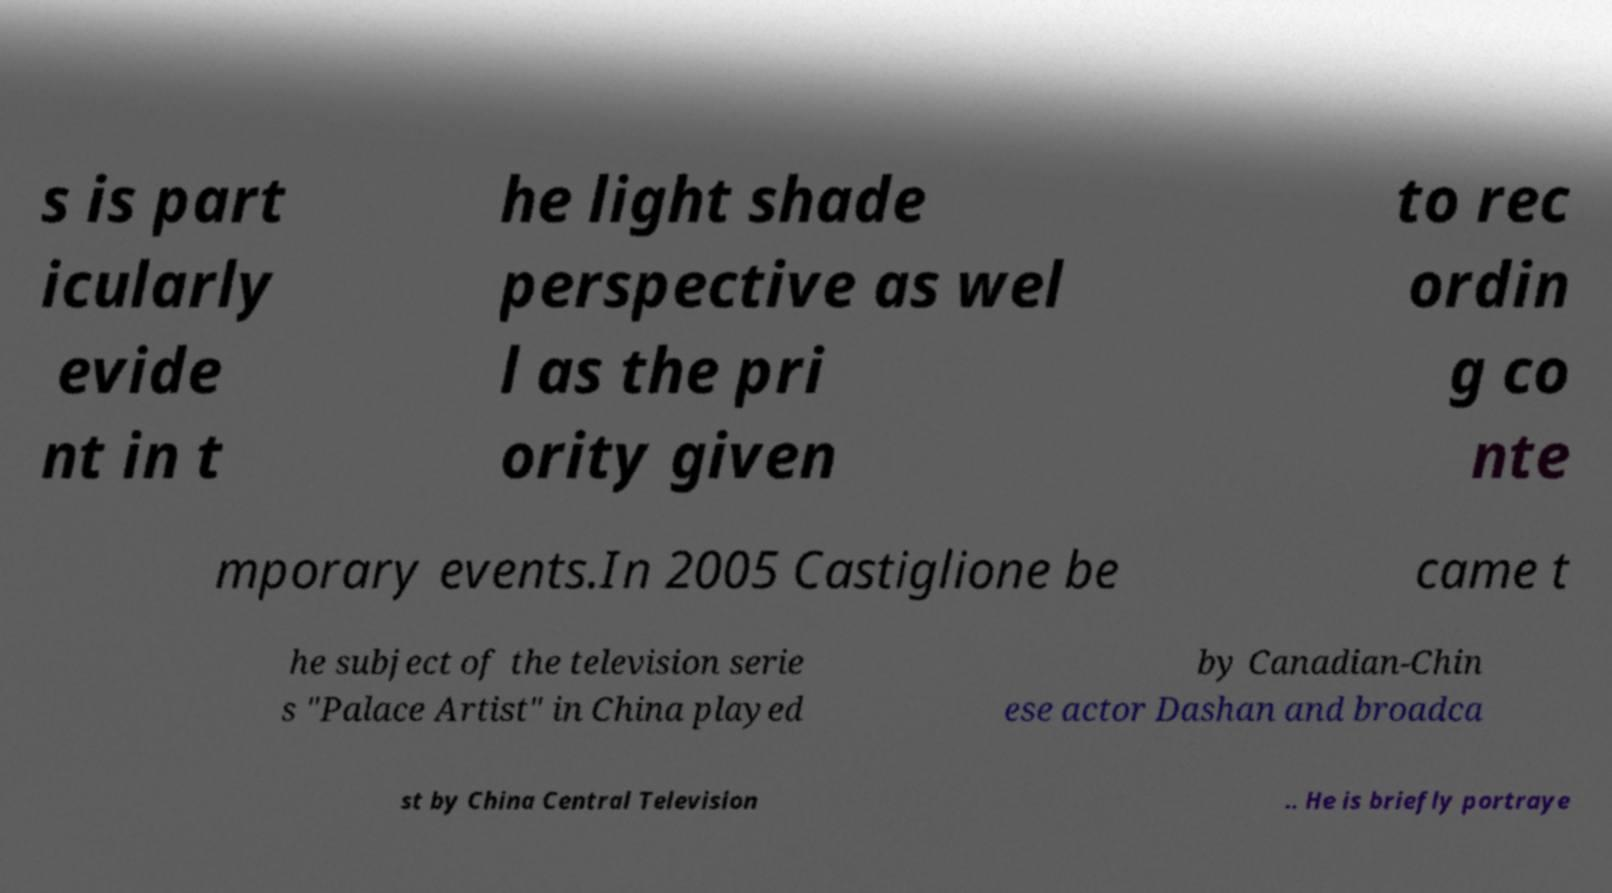Can you read and provide the text displayed in the image?This photo seems to have some interesting text. Can you extract and type it out for me? s is part icularly evide nt in t he light shade perspective as wel l as the pri ority given to rec ordin g co nte mporary events.In 2005 Castiglione be came t he subject of the television serie s "Palace Artist" in China played by Canadian-Chin ese actor Dashan and broadca st by China Central Television .. He is briefly portraye 